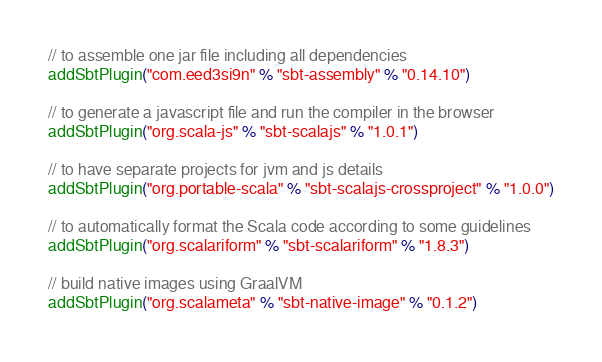<code> <loc_0><loc_0><loc_500><loc_500><_Scala_>// to assemble one jar file including all dependencies
addSbtPlugin("com.eed3si9n" % "sbt-assembly" % "0.14.10")

// to generate a javascript file and run the compiler in the browser
addSbtPlugin("org.scala-js" % "sbt-scalajs" % "1.0.1")

// to have separate projects for jvm and js details
addSbtPlugin("org.portable-scala" % "sbt-scalajs-crossproject" % "1.0.0")

// to automatically format the Scala code according to some guidelines
addSbtPlugin("org.scalariform" % "sbt-scalariform" % "1.8.3")

// build native images using GraalVM
addSbtPlugin("org.scalameta" % "sbt-native-image" % "0.1.2")</code> 